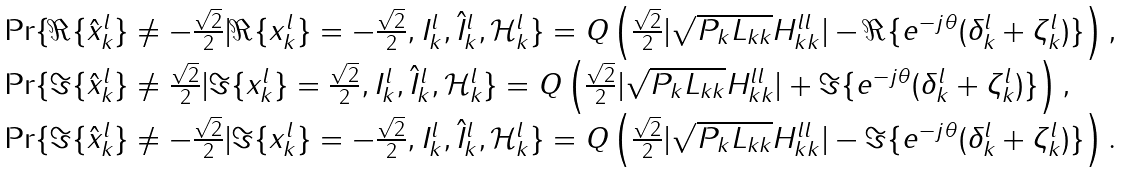<formula> <loc_0><loc_0><loc_500><loc_500>\begin{array} { l } \Pr \{ \Re \{ \hat { x } _ { k } ^ { l } \} \neq - \frac { \sqrt { 2 } } { 2 } | \Re \{ x _ { k } ^ { l } \} = - \frac { \sqrt { 2 } } { 2 } , I _ { k } ^ { l } , \hat { I } _ { k } ^ { l } , \mathcal { H } _ { k } ^ { l } \} = Q \left ( \frac { \sqrt { 2 } } { 2 } | \sqrt { P _ { k } L _ { k k } } H _ { k k } ^ { l l } | - \Re \{ e ^ { - j \theta } ( \delta _ { k } ^ { l } + \zeta _ { k } ^ { l } ) \} \right ) , \\ \Pr \{ \Im \{ \hat { x } _ { k } ^ { l } \} \neq \frac { \sqrt { 2 } } { 2 } | \Im \{ x _ { k } ^ { l } \} = \frac { \sqrt { 2 } } { 2 } , I _ { k } ^ { l } , \hat { I } _ { k } ^ { l } , \mathcal { H } _ { k } ^ { l } \} = Q \left ( \frac { \sqrt { 2 } } { 2 } | \sqrt { P _ { k } L _ { k k } } H _ { k k } ^ { l l } | + \Im \{ e ^ { - j \theta } ( \delta _ { k } ^ { l } + \zeta _ { k } ^ { l } ) \} \right ) , \\ \Pr \{ \Im \{ \hat { x } _ { k } ^ { l } \} \neq - \frac { \sqrt { 2 } } { 2 } | \Im \{ x _ { k } ^ { l } \} = - \frac { \sqrt { 2 } } { 2 } , I _ { k } ^ { l } , \hat { I } _ { k } ^ { l } , \mathcal { H } _ { k } ^ { l } \} = Q \left ( \frac { \sqrt { 2 } } { 2 } | \sqrt { P _ { k } L _ { k k } } H _ { k k } ^ { l l } | - \Im \{ e ^ { - j \theta } ( \delta _ { k } ^ { l } + \zeta _ { k } ^ { l } ) \} \right ) . \end{array}</formula> 